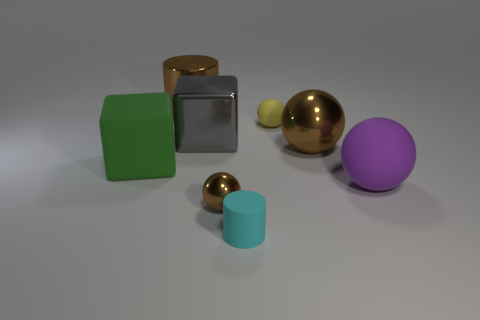What is the shape of the large metallic object that is the same color as the large cylinder?
Offer a terse response. Sphere. There is a matte object that is to the left of the small cyan matte thing; is it the same color as the big metal object that is to the right of the small yellow object?
Provide a short and direct response. No. How many big objects are both to the left of the purple matte sphere and on the right side of the gray metal cube?
Your answer should be very brief. 1. What is the material of the big purple ball?
Give a very brief answer. Rubber. The brown thing that is the same size as the yellow ball is what shape?
Offer a very short reply. Sphere. Do the cube that is on the left side of the big metal block and the brown ball that is left of the small yellow rubber ball have the same material?
Keep it short and to the point. No. How many big brown things are there?
Your answer should be very brief. 2. How many large green matte things have the same shape as the purple thing?
Your response must be concise. 0. Does the big green thing have the same shape as the gray object?
Make the answer very short. Yes. What size is the yellow sphere?
Offer a terse response. Small. 